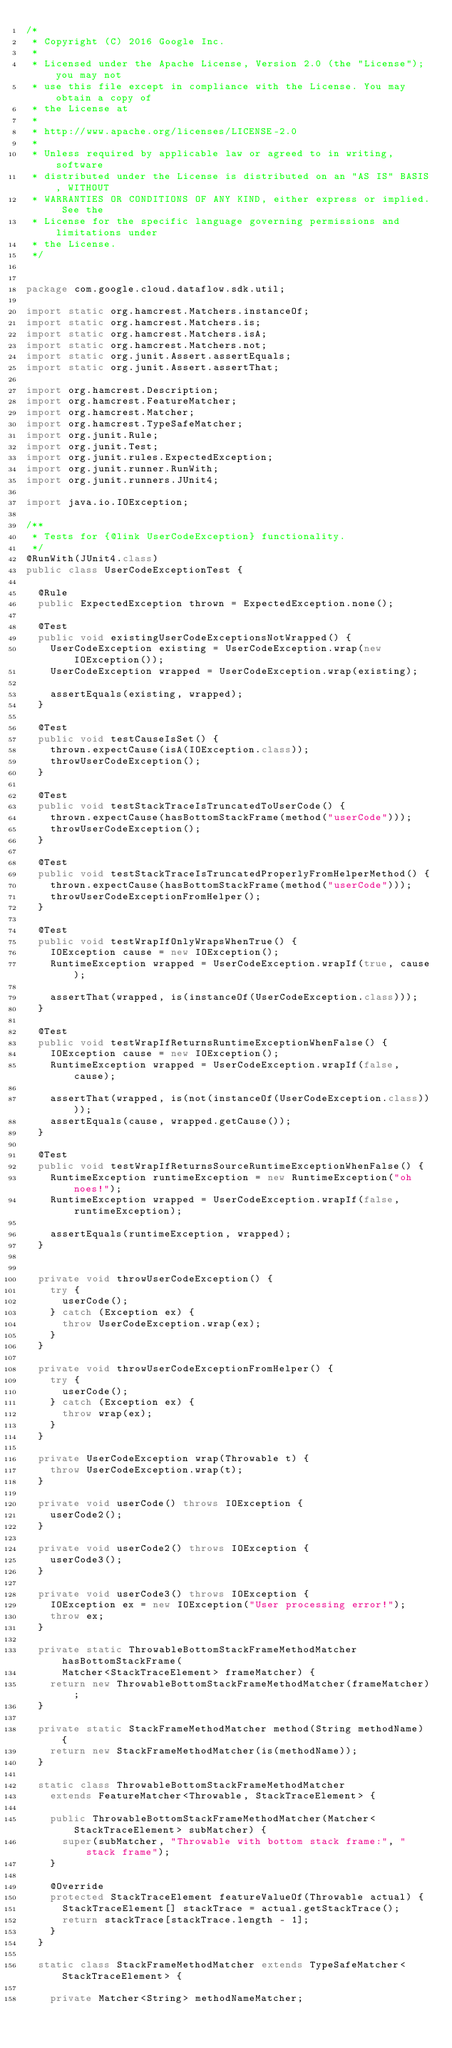<code> <loc_0><loc_0><loc_500><loc_500><_Java_>/*
 * Copyright (C) 2016 Google Inc.
 *
 * Licensed under the Apache License, Version 2.0 (the "License"); you may not
 * use this file except in compliance with the License. You may obtain a copy of
 * the License at
 *
 * http://www.apache.org/licenses/LICENSE-2.0
 *
 * Unless required by applicable law or agreed to in writing, software
 * distributed under the License is distributed on an "AS IS" BASIS, WITHOUT
 * WARRANTIES OR CONDITIONS OF ANY KIND, either express or implied. See the
 * License for the specific language governing permissions and limitations under
 * the License.
 */


package com.google.cloud.dataflow.sdk.util;

import static org.hamcrest.Matchers.instanceOf;
import static org.hamcrest.Matchers.is;
import static org.hamcrest.Matchers.isA;
import static org.hamcrest.Matchers.not;
import static org.junit.Assert.assertEquals;
import static org.junit.Assert.assertThat;

import org.hamcrest.Description;
import org.hamcrest.FeatureMatcher;
import org.hamcrest.Matcher;
import org.hamcrest.TypeSafeMatcher;
import org.junit.Rule;
import org.junit.Test;
import org.junit.rules.ExpectedException;
import org.junit.runner.RunWith;
import org.junit.runners.JUnit4;

import java.io.IOException;

/**
 * Tests for {@link UserCodeException} functionality.
 */
@RunWith(JUnit4.class)
public class UserCodeExceptionTest {

  @Rule
  public ExpectedException thrown = ExpectedException.none();

  @Test
  public void existingUserCodeExceptionsNotWrapped() {
    UserCodeException existing = UserCodeException.wrap(new IOException());
    UserCodeException wrapped = UserCodeException.wrap(existing);

    assertEquals(existing, wrapped);
  }

  @Test
  public void testCauseIsSet() {
    thrown.expectCause(isA(IOException.class));
    throwUserCodeException();
  }

  @Test
  public void testStackTraceIsTruncatedToUserCode() {
    thrown.expectCause(hasBottomStackFrame(method("userCode")));
    throwUserCodeException();
  }

  @Test
  public void testStackTraceIsTruncatedProperlyFromHelperMethod() {
    thrown.expectCause(hasBottomStackFrame(method("userCode")));
    throwUserCodeExceptionFromHelper();
  }

  @Test
  public void testWrapIfOnlyWrapsWhenTrue() {
    IOException cause = new IOException();
    RuntimeException wrapped = UserCodeException.wrapIf(true, cause);

    assertThat(wrapped, is(instanceOf(UserCodeException.class)));
  }

  @Test
  public void testWrapIfReturnsRuntimeExceptionWhenFalse() {
    IOException cause = new IOException();
    RuntimeException wrapped = UserCodeException.wrapIf(false, cause);

    assertThat(wrapped, is(not(instanceOf(UserCodeException.class))));
    assertEquals(cause, wrapped.getCause());
  }

  @Test
  public void testWrapIfReturnsSourceRuntimeExceptionWhenFalse() {
    RuntimeException runtimeException = new RuntimeException("oh noes!");
    RuntimeException wrapped = UserCodeException.wrapIf(false, runtimeException);

    assertEquals(runtimeException, wrapped);
  }


  private void throwUserCodeException() {
    try {
      userCode();
    } catch (Exception ex) {
      throw UserCodeException.wrap(ex);
    }
  }

  private void throwUserCodeExceptionFromHelper() {
    try {
      userCode();
    } catch (Exception ex) {
      throw wrap(ex);
    }
  }

  private UserCodeException wrap(Throwable t) {
    throw UserCodeException.wrap(t);
  }

  private void userCode() throws IOException {
    userCode2();
  }

  private void userCode2() throws IOException {
    userCode3();
  }

  private void userCode3() throws IOException {
    IOException ex = new IOException("User processing error!");
    throw ex;
  }

  private static ThrowableBottomStackFrameMethodMatcher hasBottomStackFrame(
      Matcher<StackTraceElement> frameMatcher) {
    return new ThrowableBottomStackFrameMethodMatcher(frameMatcher);
  }

  private static StackFrameMethodMatcher method(String methodName) {
    return new StackFrameMethodMatcher(is(methodName));
  }

  static class ThrowableBottomStackFrameMethodMatcher
    extends FeatureMatcher<Throwable, StackTraceElement> {

    public ThrowableBottomStackFrameMethodMatcher(Matcher<StackTraceElement> subMatcher) {
      super(subMatcher, "Throwable with bottom stack frame:", "stack frame");
    }

    @Override
    protected StackTraceElement featureValueOf(Throwable actual) {
      StackTraceElement[] stackTrace = actual.getStackTrace();
      return stackTrace[stackTrace.length - 1];
    }
  }

  static class StackFrameMethodMatcher extends TypeSafeMatcher<StackTraceElement> {

    private Matcher<String> methodNameMatcher;
</code> 